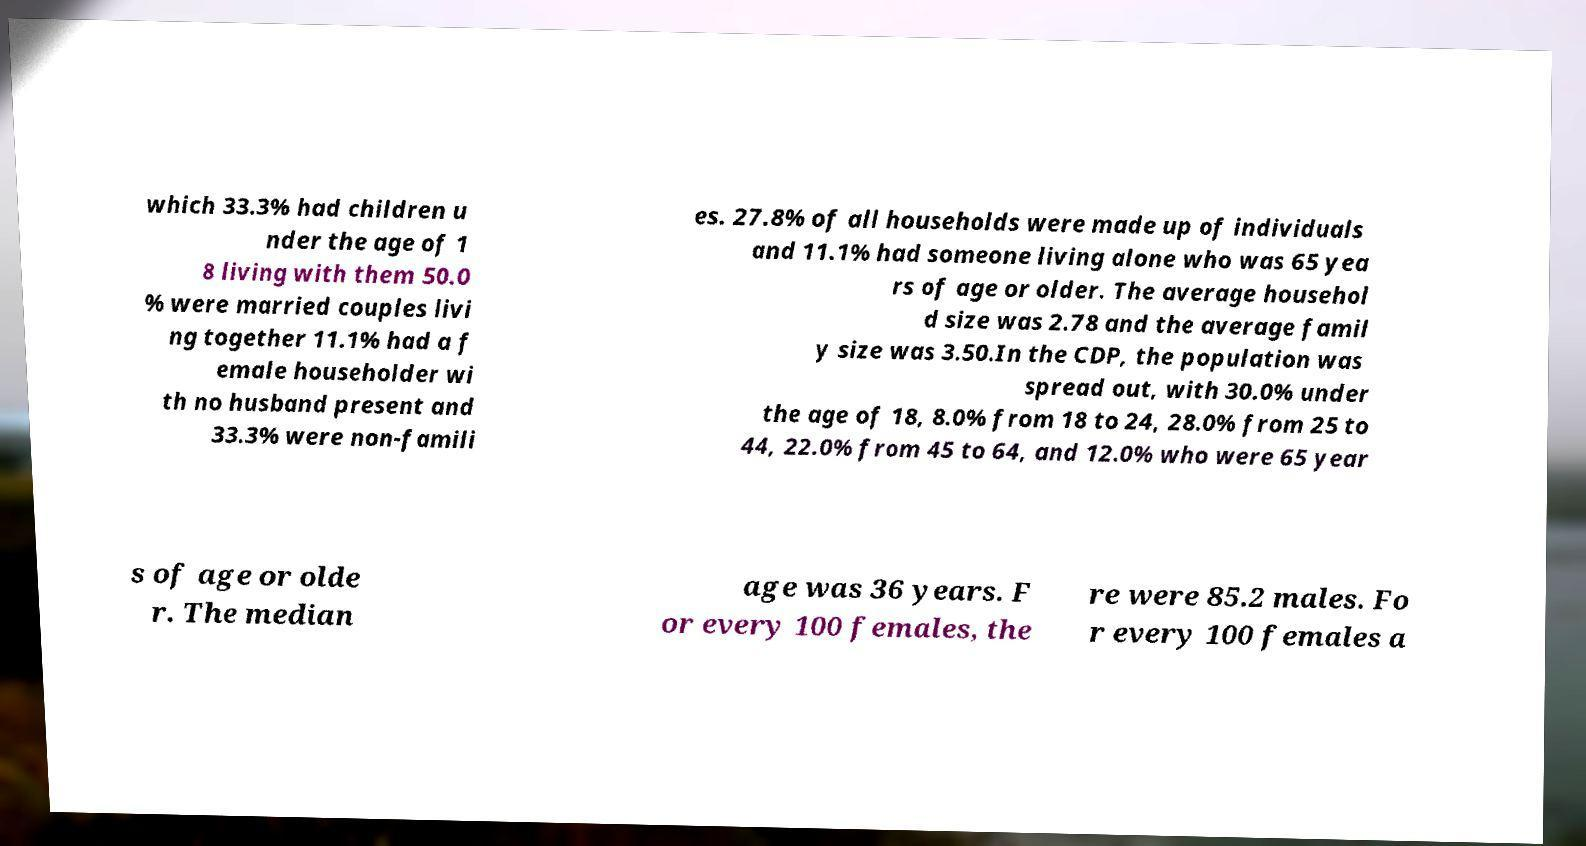For documentation purposes, I need the text within this image transcribed. Could you provide that? which 33.3% had children u nder the age of 1 8 living with them 50.0 % were married couples livi ng together 11.1% had a f emale householder wi th no husband present and 33.3% were non-famili es. 27.8% of all households were made up of individuals and 11.1% had someone living alone who was 65 yea rs of age or older. The average househol d size was 2.78 and the average famil y size was 3.50.In the CDP, the population was spread out, with 30.0% under the age of 18, 8.0% from 18 to 24, 28.0% from 25 to 44, 22.0% from 45 to 64, and 12.0% who were 65 year s of age or olde r. The median age was 36 years. F or every 100 females, the re were 85.2 males. Fo r every 100 females a 